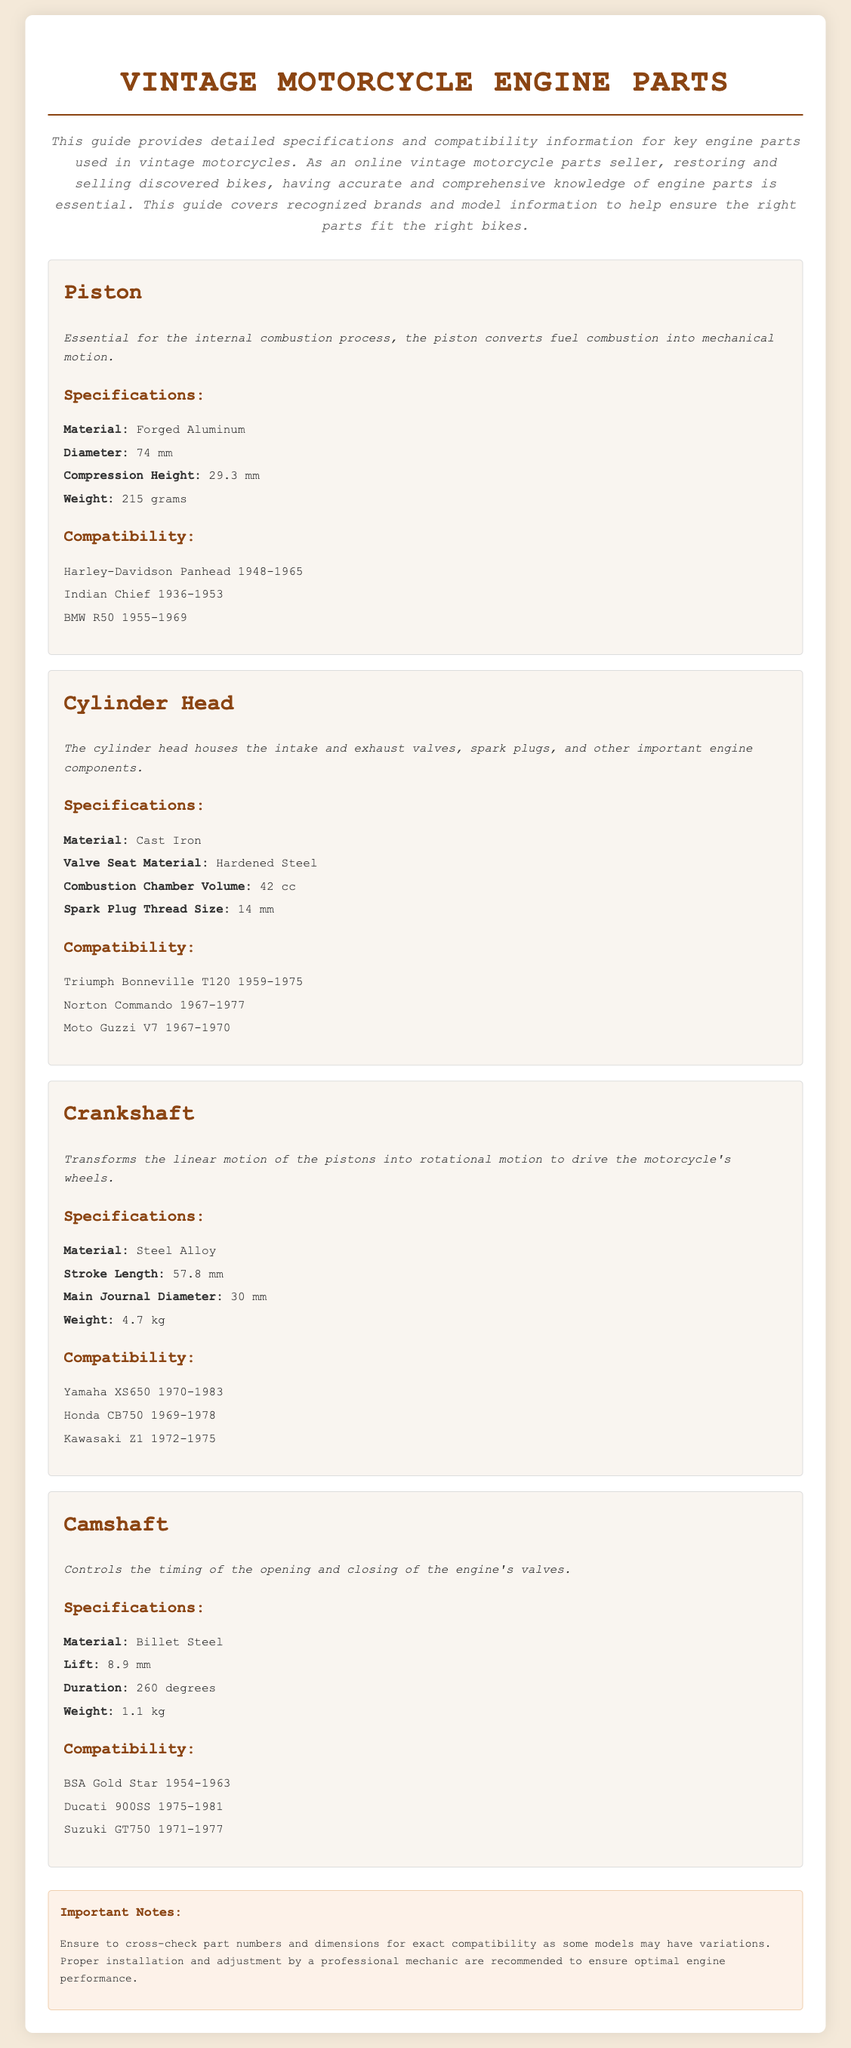What is the diameter of the piston? The diameter of the piston is specified in the document under specifications, which states it is 74 mm.
Answer: 74 mm What material is the cylinder head made of? The document lists the material of the cylinder head in the specifications section, showing it is made of Cast Iron.
Answer: Cast Iron What is the weight of the crankshaft? The weight of the crankshaft is provided in the specifications section, where it mentions it weighs 4.7 kg.
Answer: 4.7 kg Which models is the piston compatible with? The compatibility section for the piston lists several models, including Harley-Davidson Panhead 1948-1965.
Answer: Harley-Davidson Panhead 1948-1965 What is the lift of the camshaft? The lift of the camshaft is found in the specifications, showing it is 8.9 mm.
Answer: 8.9 mm How many cc is the combustion chamber volume of the cylinder head? The combustion chamber volume is given in the specifications, indicating it is 42 cc.
Answer: 42 cc Which material is used for the camshaft? The document specifies the camshaft's material in the specifications section, which is Billet Steel.
Answer: Billet Steel What is the compatibility of the crankshaft? The compatibility section for the crankshaft mentions it is compatible with Yamaha XS650 1970-1983.
Answer: Yamaha XS650 1970-1983 What should be ensured for compatibility? The notes indicate that it is important to cross-check part numbers and dimensions for compatibility.
Answer: Cross-check part numbers and dimensions 